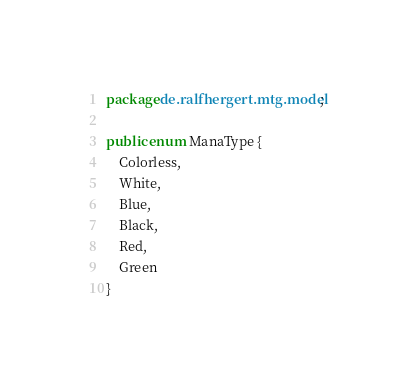<code> <loc_0><loc_0><loc_500><loc_500><_Java_>package de.ralfhergert.mtg.model;

public enum ManaType {
    Colorless,
    White,
    Blue,
    Black,
    Red,
    Green
}
</code> 